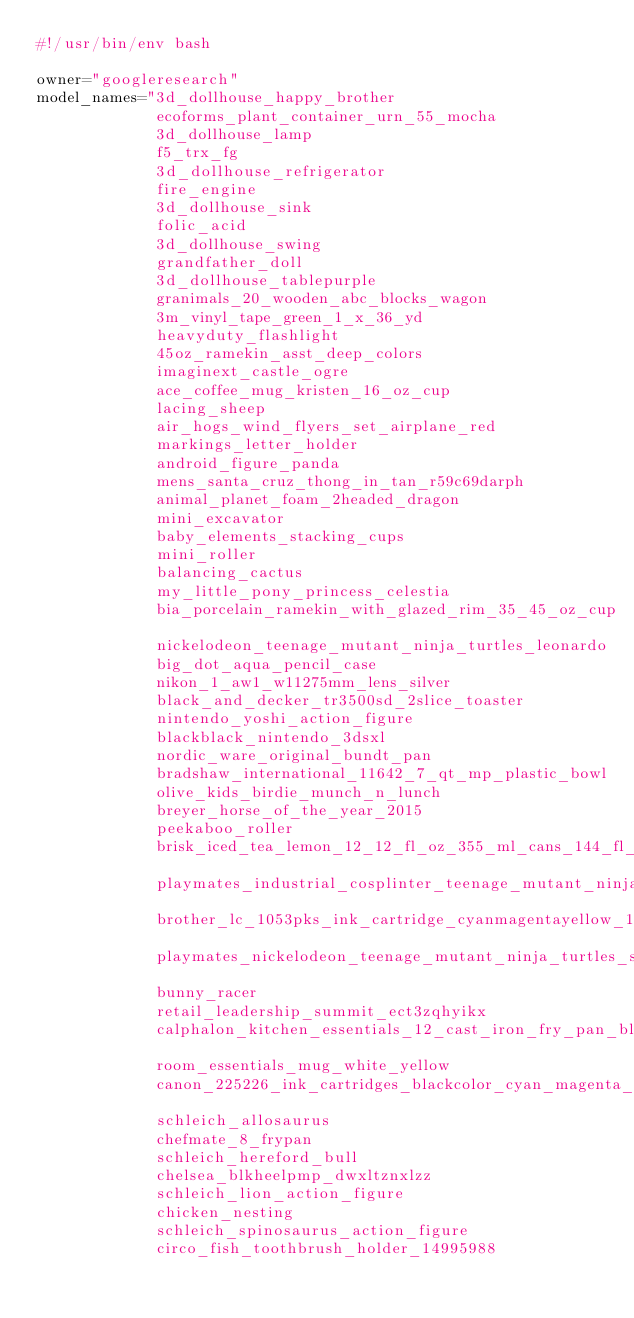<code> <loc_0><loc_0><loc_500><loc_500><_Bash_>#!/usr/bin/env bash

owner="googleresearch"
model_names="3d_dollhouse_happy_brother
             ecoforms_plant_container_urn_55_mocha
             3d_dollhouse_lamp
             f5_trx_fg
             3d_dollhouse_refrigerator
             fire_engine
             3d_dollhouse_sink
             folic_acid
             3d_dollhouse_swing
             grandfather_doll
             3d_dollhouse_tablepurple
             granimals_20_wooden_abc_blocks_wagon
             3m_vinyl_tape_green_1_x_36_yd
             heavyduty_flashlight
             45oz_ramekin_asst_deep_colors
             imaginext_castle_ogre
             ace_coffee_mug_kristen_16_oz_cup
             lacing_sheep
             air_hogs_wind_flyers_set_airplane_red
             markings_letter_holder
             android_figure_panda
             mens_santa_cruz_thong_in_tan_r59c69darph
             animal_planet_foam_2headed_dragon
             mini_excavator
             baby_elements_stacking_cups
             mini_roller
             balancing_cactus
             my_little_pony_princess_celestia
             bia_porcelain_ramekin_with_glazed_rim_35_45_oz_cup
             nickelodeon_teenage_mutant_ninja_turtles_leonardo
             big_dot_aqua_pencil_case
             nikon_1_aw1_w11275mm_lens_silver
             black_and_decker_tr3500sd_2slice_toaster
             nintendo_yoshi_action_figure
             blackblack_nintendo_3dsxl
             nordic_ware_original_bundt_pan
             bradshaw_international_11642_7_qt_mp_plastic_bowl
             olive_kids_birdie_munch_n_lunch
             breyer_horse_of_the_year_2015
             peekaboo_roller
             brisk_iced_tea_lemon_12_12_fl_oz_355_ml_cans_144_fl_oz_426_lt
             playmates_industrial_cosplinter_teenage_mutant_ninja_turtle_action_figure
             brother_lc_1053pks_ink_cartridge_cyanmagentayellow_1pack
             playmates_nickelodeon_teenage_mutant_ninja_turtles_shredder
             bunny_racer
             retail_leadership_summit_ect3zqhyikx
             calphalon_kitchen_essentials_12_cast_iron_fry_pan_black
             room_essentials_mug_white_yellow
             canon_225226_ink_cartridges_blackcolor_cyan_magenta_yellow_6_count
             schleich_allosaurus
             chefmate_8_frypan
             schleich_hereford_bull
             chelsea_blkheelpmp_dwxltznxlzz
             schleich_lion_action_figure
             chicken_nesting
             schleich_spinosaurus_action_figure
             circo_fish_toothbrush_holder_14995988</code> 